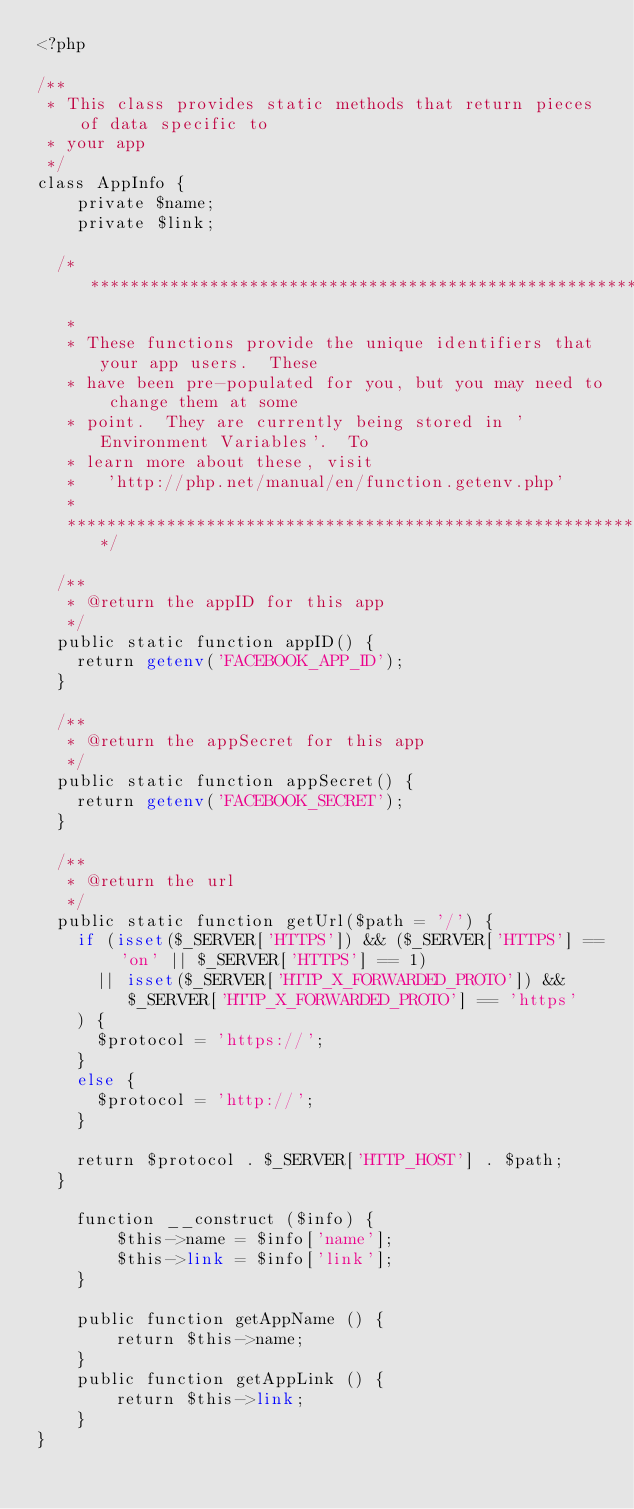Convert code to text. <code><loc_0><loc_0><loc_500><loc_500><_PHP_><?php

/**
 * This class provides static methods that return pieces of data specific to
 * your app
 */
class AppInfo {
    private $name;
    private $link;

  /*****************************************************************************
   *
   * These functions provide the unique identifiers that your app users.  These
   * have been pre-populated for you, but you may need to change them at some
   * point.  They are currently being stored in 'Environment Variables'.  To
   * learn more about these, visit
   *   'http://php.net/manual/en/function.getenv.php'
   *
   ****************************************************************************/

  /**
   * @return the appID for this app
   */
  public static function appID() {
    return getenv('FACEBOOK_APP_ID');
  }

  /**
   * @return the appSecret for this app
   */
  public static function appSecret() {
    return getenv('FACEBOOK_SECRET');
  }

  /**
   * @return the url
   */
  public static function getUrl($path = '/') {
    if (isset($_SERVER['HTTPS']) && ($_SERVER['HTTPS'] == 'on' || $_SERVER['HTTPS'] == 1)
      || isset($_SERVER['HTTP_X_FORWARDED_PROTO']) && $_SERVER['HTTP_X_FORWARDED_PROTO'] == 'https'
    ) {
      $protocol = 'https://';
    }
    else {
      $protocol = 'http://';
    }

    return $protocol . $_SERVER['HTTP_HOST'] . $path;
  }

    function __construct ($info) {
        $this->name = $info['name'];
        $this->link = $info['link'];
    }

    public function getAppName () {
        return $this->name;
    }
    public function getAppLink () {
        return $this->link;
    }
}
</code> 